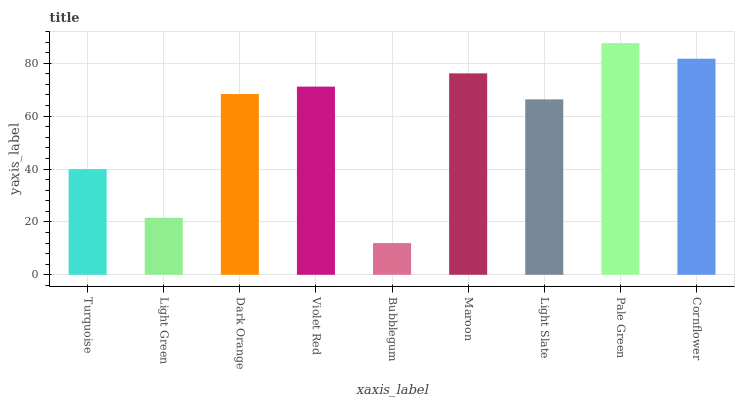Is Bubblegum the minimum?
Answer yes or no. Yes. Is Pale Green the maximum?
Answer yes or no. Yes. Is Light Green the minimum?
Answer yes or no. No. Is Light Green the maximum?
Answer yes or no. No. Is Turquoise greater than Light Green?
Answer yes or no. Yes. Is Light Green less than Turquoise?
Answer yes or no. Yes. Is Light Green greater than Turquoise?
Answer yes or no. No. Is Turquoise less than Light Green?
Answer yes or no. No. Is Dark Orange the high median?
Answer yes or no. Yes. Is Dark Orange the low median?
Answer yes or no. Yes. Is Bubblegum the high median?
Answer yes or no. No. Is Light Slate the low median?
Answer yes or no. No. 